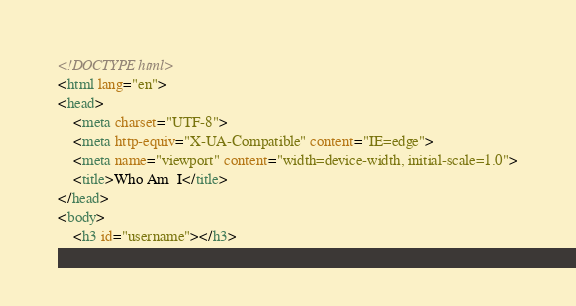Convert code to text. <code><loc_0><loc_0><loc_500><loc_500><_HTML_><!DOCTYPE html>
<html lang="en">
<head>
    <meta charset="UTF-8">
    <meta http-equiv="X-UA-Compatible" content="IE=edge">
    <meta name="viewport" content="width=device-width, initial-scale=1.0">
    <title>Who Am  I</title>
</head>
<body>
    <h3 id="username"></h3></code> 